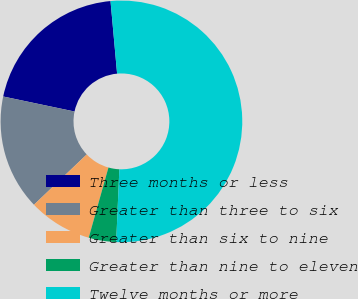Convert chart to OTSL. <chart><loc_0><loc_0><loc_500><loc_500><pie_chart><fcel>Three months or less<fcel>Greater than three to six<fcel>Greater than six to nine<fcel>Greater than nine to eleven<fcel>Twelve months or more<nl><fcel>20.26%<fcel>15.42%<fcel>8.52%<fcel>3.67%<fcel>52.13%<nl></chart> 